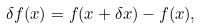Convert formula to latex. <formula><loc_0><loc_0><loc_500><loc_500>\delta f ( x ) = f ( x + \delta x ) - f ( x ) ,</formula> 